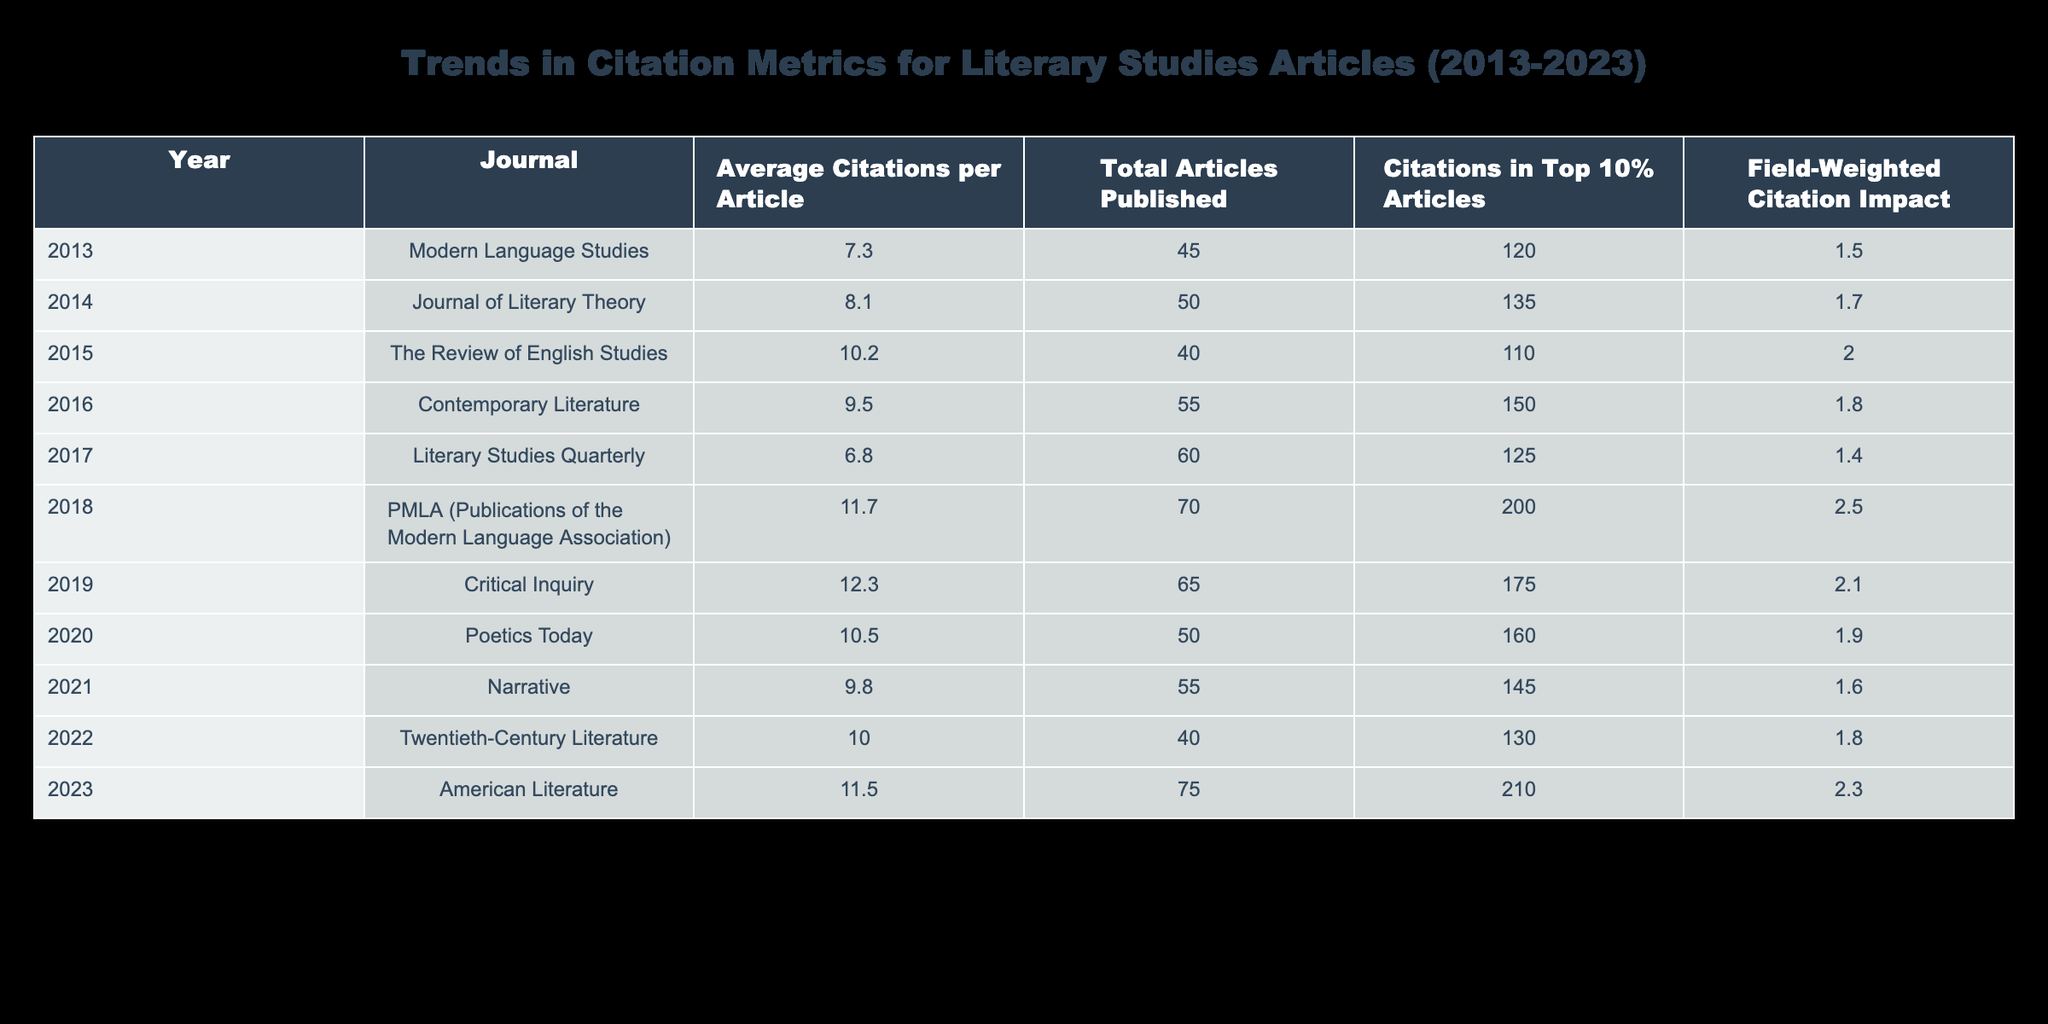What was the year with the highest average citations per article? Looking through the “Average Citations per Article” column, the highest value is 12.3, which corresponds to the year 2019.
Answer: 2019 What is the total number of articles published in 2018? The table shows that the number of articles published in the year 2018 is 70.
Answer: 70 Which journal had the highest field-weighted citation impact in 2023? The “Field-Weighted Citation Impact” for the year 2023 shows a value of 2.3 for the journal "American Literature," which is the highest among all journals listed.
Answer: American Literature Is the average citations per article for 2016 greater than that of 2015? The average citations per article for 2016 is 9.5 and for 2015 it is 10.2. Since 9.5 is not greater than 10.2, the statement is false.
Answer: No What was the total number of citations in the top 10% articles for all years combined? Summing the values of citations in the top 10% articles for each year: (120 + 135 + 110 + 150 + 125 + 200 + 175 + 160 + 145 + 130 + 210) gives a total of 1,610 citations.
Answer: 1610 Which year had the most articles published, and what was that number? By observing the “Total Articles Published” column, 2017 has the highest number of articles published at 60.
Answer: 60 Was there a year when the average citations per article exceeded 11? Yes, looking through the "Average Citations per Article" column, the years 2018, 2019, and 2023 all have values exceeding 11.
Answer: Yes What journal had the lowest citations in the top 10% articles over the period? The table shows that "The Review of English Studies" had the lowest citations in the top 10% articles with a value of 110 in 2015.
Answer: The Review of English Studies What is the difference in average citations per article between 2013 and 2020? The average citations per article for 2013 is 7.3 and for 2020 it's 10.5. The difference is 10.5 - 7.3 = 3.2.
Answer: 3.2 